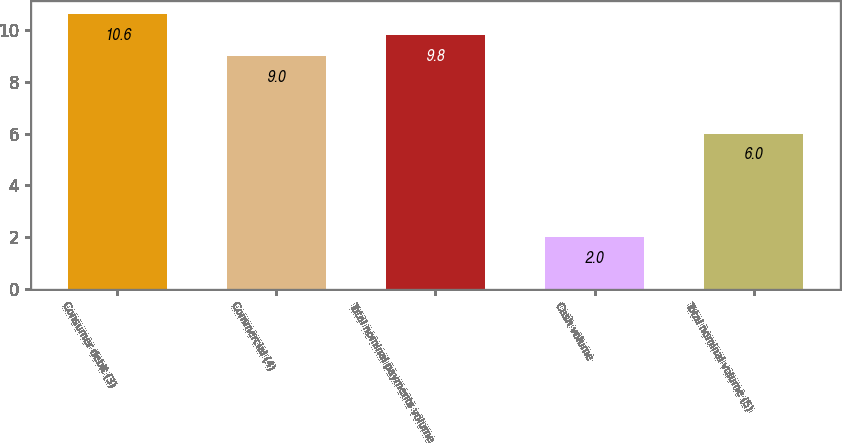<chart> <loc_0><loc_0><loc_500><loc_500><bar_chart><fcel>Consumer debit (3)<fcel>Commercial (4)<fcel>Total nominal payments volume<fcel>Cash volume<fcel>Total nominal volume (5)<nl><fcel>10.6<fcel>9<fcel>9.8<fcel>2<fcel>6<nl></chart> 